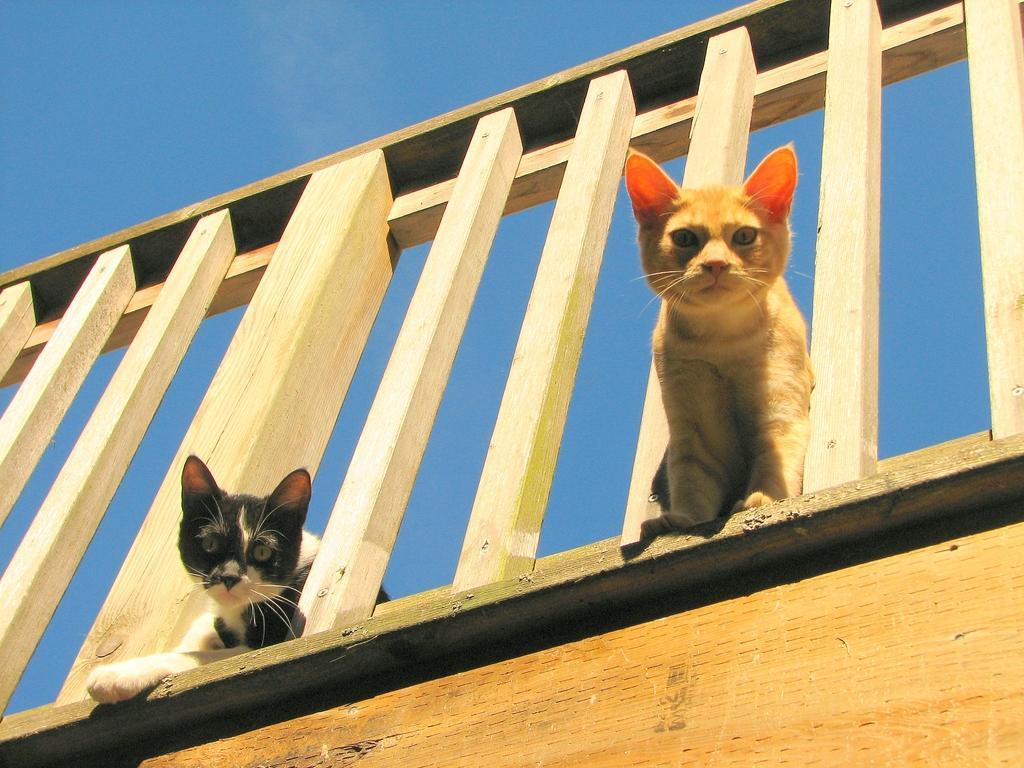Could you give a brief overview of what you see in this image? In the background portion of the picture we can see a clear blue sky. In this picture we can see two cats and a wooden fence. At the bottom portion of the picture we can see a wooden board. 